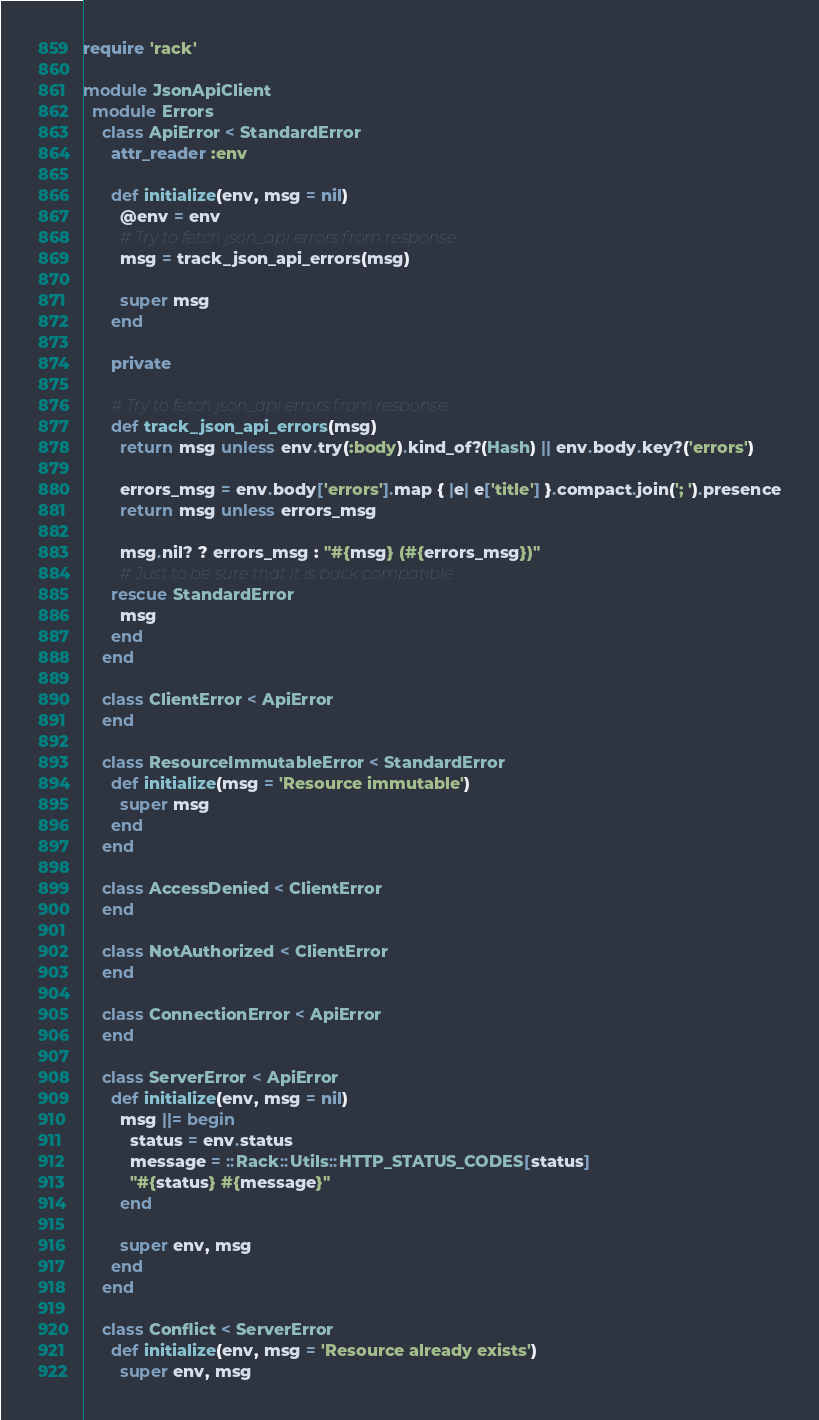<code> <loc_0><loc_0><loc_500><loc_500><_Ruby_>require 'rack'

module JsonApiClient
  module Errors
    class ApiError < StandardError
      attr_reader :env

      def initialize(env, msg = nil)
        @env = env
        # Try to fetch json_api errors from response
        msg = track_json_api_errors(msg)

        super msg
      end

      private

      # Try to fetch json_api errors from response
      def track_json_api_errors(msg)
        return msg unless env.try(:body).kind_of?(Hash) || env.body.key?('errors')

        errors_msg = env.body['errors'].map { |e| e['title'] }.compact.join('; ').presence
        return msg unless errors_msg

        msg.nil? ? errors_msg : "#{msg} (#{errors_msg})"
        # Just to be sure that it is back compatible
      rescue StandardError
        msg
      end
    end

    class ClientError < ApiError
    end

    class ResourceImmutableError < StandardError
      def initialize(msg = 'Resource immutable')
        super msg
      end
    end

    class AccessDenied < ClientError
    end

    class NotAuthorized < ClientError
    end

    class ConnectionError < ApiError
    end

    class ServerError < ApiError
      def initialize(env, msg = nil)
        msg ||= begin
          status = env.status
          message = ::Rack::Utils::HTTP_STATUS_CODES[status]
          "#{status} #{message}"
        end

        super env, msg
      end
    end

    class Conflict < ServerError
      def initialize(env, msg = 'Resource already exists')
        super env, msg</code> 